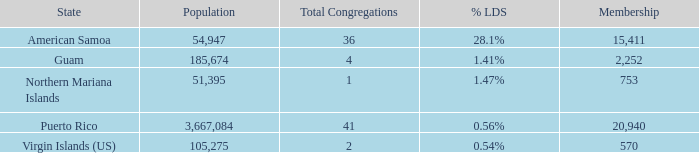What is the highest Population, when State is Puerto Rico, and when Total Congregations is greater than 41? None. 